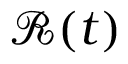<formula> <loc_0><loc_0><loc_500><loc_500>\mathcal { R } ( t )</formula> 